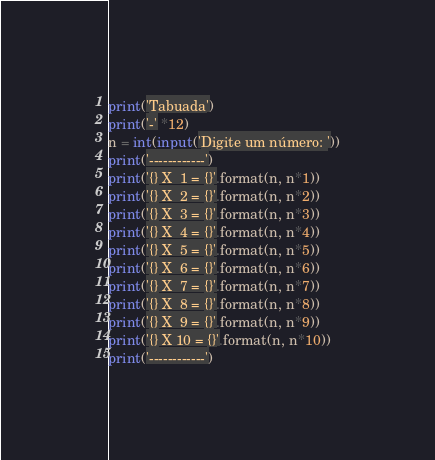Convert code to text. <code><loc_0><loc_0><loc_500><loc_500><_Python_>print('Tabuada')
print('-' *12)
n = int(input('Digite um número: '))
print('------------')
print('{} X  1 = {}'.format(n, n*1))
print('{} X  2 = {}'.format(n, n*2))
print('{} X  3 = {}'.format(n, n*3))
print('{} X  4 = {}'.format(n, n*4))
print('{} X  5 = {}'.format(n, n*5))
print('{} X  6 = {}'.format(n, n*6))
print('{} X  7 = {}'.format(n, n*7))
print('{} X  8 = {}'.format(n, n*8))
print('{} X  9 = {}'.format(n, n*9))
print('{} X 10 = {}'.format(n, n*10))
print('------------')
</code> 